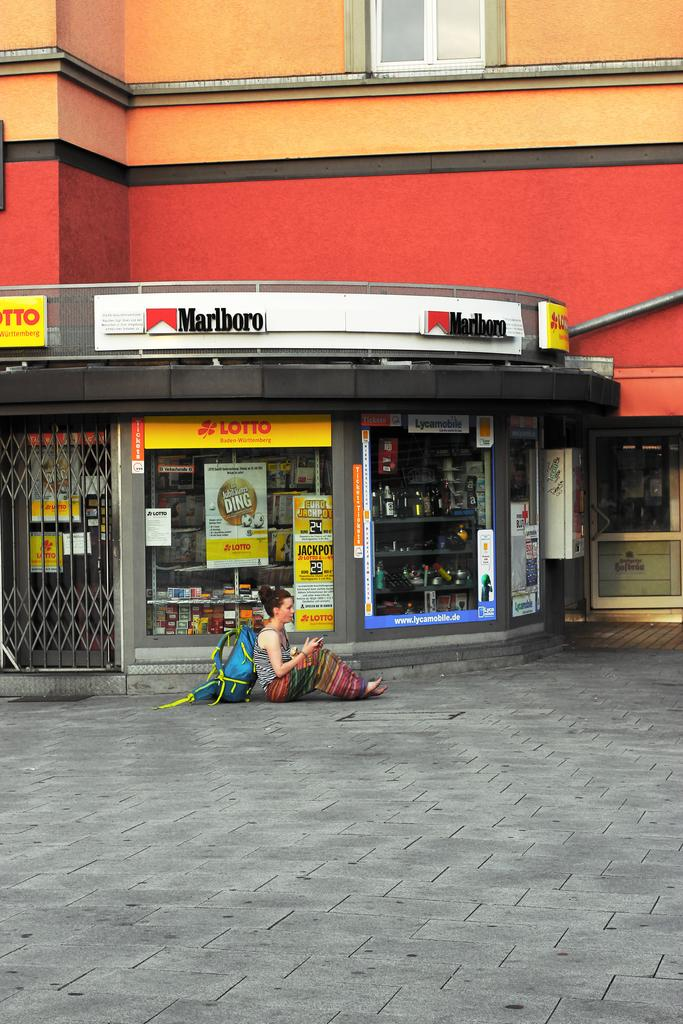Provide a one-sentence caption for the provided image. A woman with a blue backpack sits on the ground outside of a store with a Lotto sign and a Marlboro sign. 